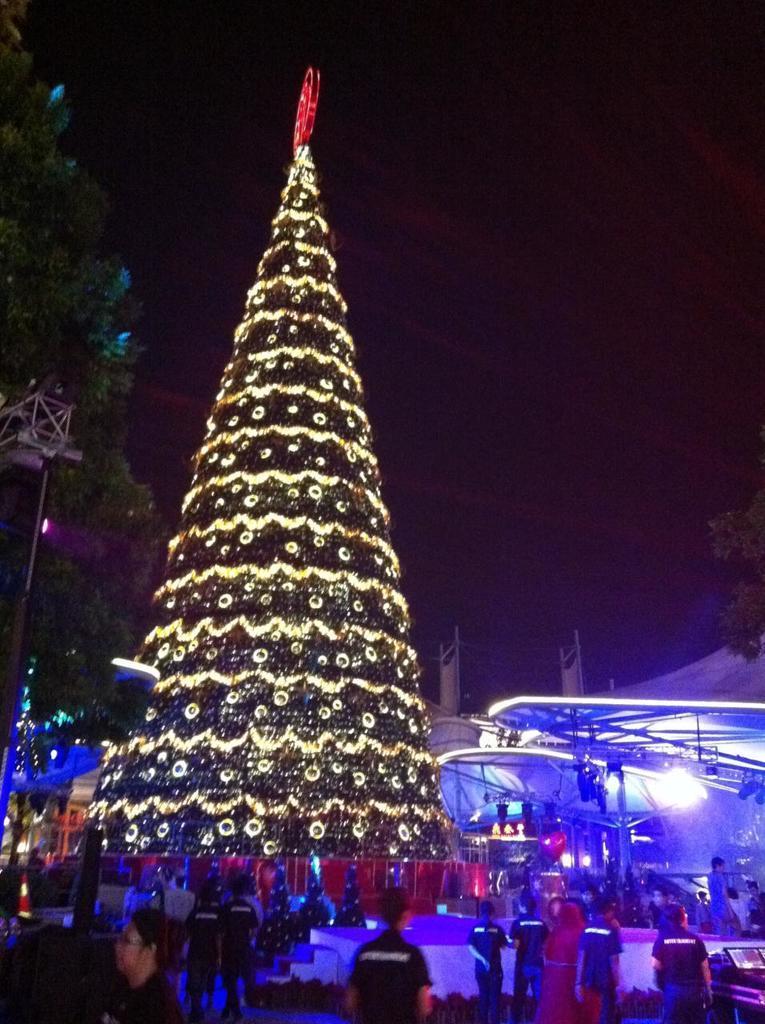Can you describe this image briefly? In this image, on the left side, we can see a person, on the left side, we can see two men. On the left side, we can also see some trees, metal instrument. On the right side, we can see a group of people, vehicles, roof with few lights. In the middle of the image, we can see a group of people, Christmas tree. In the background, we can also see some tables, chairs. At the top, we can see black color. 